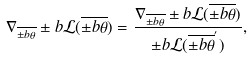Convert formula to latex. <formula><loc_0><loc_0><loc_500><loc_500>\nabla _ { \overline { \pm b { \theta } } } \pm b { \mathcal { L } } ( \overline { \pm b { \theta } } ) = \frac { \nabla _ { \overline { \pm b { \theta } } } \pm b { \mathcal { L } } ( \overline { \pm b { \theta } } ) } { \pm b { \mathcal { L } } ( \overline { \pm b { \theta } } ^ { ^ { \prime } } ) } ,</formula> 